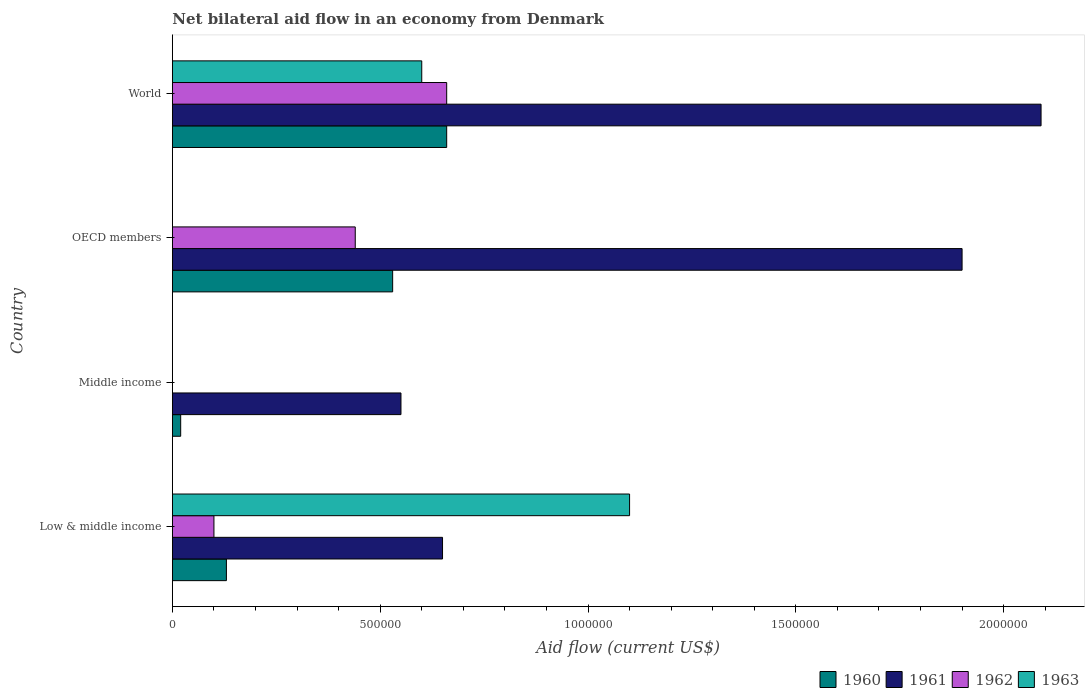How many different coloured bars are there?
Your answer should be compact. 4. Are the number of bars per tick equal to the number of legend labels?
Keep it short and to the point. No. Are the number of bars on each tick of the Y-axis equal?
Provide a succinct answer. No. What is the label of the 3rd group of bars from the top?
Your answer should be compact. Middle income. What is the net bilateral aid flow in 1963 in Low & middle income?
Provide a short and direct response. 1.10e+06. Across all countries, what is the maximum net bilateral aid flow in 1963?
Offer a terse response. 1.10e+06. Across all countries, what is the minimum net bilateral aid flow in 1961?
Offer a terse response. 5.50e+05. What is the total net bilateral aid flow in 1961 in the graph?
Ensure brevity in your answer.  5.19e+06. What is the difference between the net bilateral aid flow in 1960 in OECD members and the net bilateral aid flow in 1962 in Low & middle income?
Offer a very short reply. 4.30e+05. What is the average net bilateral aid flow in 1963 per country?
Your answer should be very brief. 4.25e+05. What is the difference between the net bilateral aid flow in 1961 and net bilateral aid flow in 1963 in Low & middle income?
Provide a succinct answer. -4.50e+05. In how many countries, is the net bilateral aid flow in 1963 greater than 1000000 US$?
Give a very brief answer. 1. What is the ratio of the net bilateral aid flow in 1961 in Middle income to that in OECD members?
Offer a terse response. 0.29. What is the difference between the highest and the lowest net bilateral aid flow in 1961?
Provide a succinct answer. 1.54e+06. Is it the case that in every country, the sum of the net bilateral aid flow in 1963 and net bilateral aid flow in 1962 is greater than the sum of net bilateral aid flow in 1961 and net bilateral aid flow in 1960?
Provide a short and direct response. No. How many bars are there?
Offer a very short reply. 13. Are all the bars in the graph horizontal?
Your response must be concise. Yes. How many countries are there in the graph?
Offer a very short reply. 4. Does the graph contain grids?
Offer a terse response. No. How many legend labels are there?
Provide a succinct answer. 4. What is the title of the graph?
Give a very brief answer. Net bilateral aid flow in an economy from Denmark. Does "1969" appear as one of the legend labels in the graph?
Give a very brief answer. No. What is the label or title of the Y-axis?
Give a very brief answer. Country. What is the Aid flow (current US$) of 1961 in Low & middle income?
Your answer should be compact. 6.50e+05. What is the Aid flow (current US$) of 1963 in Low & middle income?
Offer a very short reply. 1.10e+06. What is the Aid flow (current US$) of 1961 in Middle income?
Provide a succinct answer. 5.50e+05. What is the Aid flow (current US$) of 1962 in Middle income?
Offer a very short reply. 0. What is the Aid flow (current US$) in 1960 in OECD members?
Your answer should be very brief. 5.30e+05. What is the Aid flow (current US$) in 1961 in OECD members?
Your answer should be very brief. 1.90e+06. What is the Aid flow (current US$) in 1962 in OECD members?
Your response must be concise. 4.40e+05. What is the Aid flow (current US$) in 1963 in OECD members?
Offer a terse response. 0. What is the Aid flow (current US$) of 1960 in World?
Provide a succinct answer. 6.60e+05. What is the Aid flow (current US$) in 1961 in World?
Offer a very short reply. 2.09e+06. What is the Aid flow (current US$) in 1962 in World?
Your response must be concise. 6.60e+05. What is the Aid flow (current US$) in 1963 in World?
Your answer should be very brief. 6.00e+05. Across all countries, what is the maximum Aid flow (current US$) of 1961?
Your answer should be very brief. 2.09e+06. Across all countries, what is the maximum Aid flow (current US$) of 1963?
Keep it short and to the point. 1.10e+06. Across all countries, what is the minimum Aid flow (current US$) of 1960?
Your answer should be compact. 2.00e+04. Across all countries, what is the minimum Aid flow (current US$) in 1961?
Offer a very short reply. 5.50e+05. Across all countries, what is the minimum Aid flow (current US$) in 1962?
Give a very brief answer. 0. What is the total Aid flow (current US$) in 1960 in the graph?
Offer a very short reply. 1.34e+06. What is the total Aid flow (current US$) of 1961 in the graph?
Ensure brevity in your answer.  5.19e+06. What is the total Aid flow (current US$) of 1962 in the graph?
Provide a succinct answer. 1.20e+06. What is the total Aid flow (current US$) in 1963 in the graph?
Make the answer very short. 1.70e+06. What is the difference between the Aid flow (current US$) of 1960 in Low & middle income and that in OECD members?
Your answer should be compact. -4.00e+05. What is the difference between the Aid flow (current US$) in 1961 in Low & middle income and that in OECD members?
Your response must be concise. -1.25e+06. What is the difference between the Aid flow (current US$) of 1960 in Low & middle income and that in World?
Give a very brief answer. -5.30e+05. What is the difference between the Aid flow (current US$) of 1961 in Low & middle income and that in World?
Keep it short and to the point. -1.44e+06. What is the difference between the Aid flow (current US$) in 1962 in Low & middle income and that in World?
Ensure brevity in your answer.  -5.60e+05. What is the difference between the Aid flow (current US$) of 1960 in Middle income and that in OECD members?
Make the answer very short. -5.10e+05. What is the difference between the Aid flow (current US$) of 1961 in Middle income and that in OECD members?
Provide a short and direct response. -1.35e+06. What is the difference between the Aid flow (current US$) of 1960 in Middle income and that in World?
Provide a short and direct response. -6.40e+05. What is the difference between the Aid flow (current US$) in 1961 in Middle income and that in World?
Keep it short and to the point. -1.54e+06. What is the difference between the Aid flow (current US$) of 1960 in Low & middle income and the Aid flow (current US$) of 1961 in Middle income?
Provide a short and direct response. -4.20e+05. What is the difference between the Aid flow (current US$) in 1960 in Low & middle income and the Aid flow (current US$) in 1961 in OECD members?
Make the answer very short. -1.77e+06. What is the difference between the Aid flow (current US$) of 1960 in Low & middle income and the Aid flow (current US$) of 1962 in OECD members?
Offer a terse response. -3.10e+05. What is the difference between the Aid flow (current US$) of 1960 in Low & middle income and the Aid flow (current US$) of 1961 in World?
Provide a short and direct response. -1.96e+06. What is the difference between the Aid flow (current US$) in 1960 in Low & middle income and the Aid flow (current US$) in 1962 in World?
Provide a succinct answer. -5.30e+05. What is the difference between the Aid flow (current US$) in 1960 in Low & middle income and the Aid flow (current US$) in 1963 in World?
Provide a short and direct response. -4.70e+05. What is the difference between the Aid flow (current US$) in 1961 in Low & middle income and the Aid flow (current US$) in 1962 in World?
Provide a short and direct response. -10000. What is the difference between the Aid flow (current US$) in 1961 in Low & middle income and the Aid flow (current US$) in 1963 in World?
Your answer should be compact. 5.00e+04. What is the difference between the Aid flow (current US$) in 1962 in Low & middle income and the Aid flow (current US$) in 1963 in World?
Provide a succinct answer. -5.00e+05. What is the difference between the Aid flow (current US$) of 1960 in Middle income and the Aid flow (current US$) of 1961 in OECD members?
Provide a short and direct response. -1.88e+06. What is the difference between the Aid flow (current US$) of 1960 in Middle income and the Aid flow (current US$) of 1962 in OECD members?
Offer a very short reply. -4.20e+05. What is the difference between the Aid flow (current US$) of 1961 in Middle income and the Aid flow (current US$) of 1962 in OECD members?
Give a very brief answer. 1.10e+05. What is the difference between the Aid flow (current US$) of 1960 in Middle income and the Aid flow (current US$) of 1961 in World?
Offer a very short reply. -2.07e+06. What is the difference between the Aid flow (current US$) of 1960 in Middle income and the Aid flow (current US$) of 1962 in World?
Keep it short and to the point. -6.40e+05. What is the difference between the Aid flow (current US$) in 1960 in Middle income and the Aid flow (current US$) in 1963 in World?
Your answer should be very brief. -5.80e+05. What is the difference between the Aid flow (current US$) of 1960 in OECD members and the Aid flow (current US$) of 1961 in World?
Ensure brevity in your answer.  -1.56e+06. What is the difference between the Aid flow (current US$) in 1960 in OECD members and the Aid flow (current US$) in 1962 in World?
Your response must be concise. -1.30e+05. What is the difference between the Aid flow (current US$) in 1960 in OECD members and the Aid flow (current US$) in 1963 in World?
Your response must be concise. -7.00e+04. What is the difference between the Aid flow (current US$) in 1961 in OECD members and the Aid flow (current US$) in 1962 in World?
Keep it short and to the point. 1.24e+06. What is the difference between the Aid flow (current US$) in 1961 in OECD members and the Aid flow (current US$) in 1963 in World?
Provide a succinct answer. 1.30e+06. What is the average Aid flow (current US$) of 1960 per country?
Offer a terse response. 3.35e+05. What is the average Aid flow (current US$) of 1961 per country?
Provide a succinct answer. 1.30e+06. What is the average Aid flow (current US$) of 1962 per country?
Offer a very short reply. 3.00e+05. What is the average Aid flow (current US$) of 1963 per country?
Give a very brief answer. 4.25e+05. What is the difference between the Aid flow (current US$) of 1960 and Aid flow (current US$) of 1961 in Low & middle income?
Offer a very short reply. -5.20e+05. What is the difference between the Aid flow (current US$) of 1960 and Aid flow (current US$) of 1963 in Low & middle income?
Offer a very short reply. -9.70e+05. What is the difference between the Aid flow (current US$) of 1961 and Aid flow (current US$) of 1962 in Low & middle income?
Your answer should be very brief. 5.50e+05. What is the difference between the Aid flow (current US$) in 1961 and Aid flow (current US$) in 1963 in Low & middle income?
Keep it short and to the point. -4.50e+05. What is the difference between the Aid flow (current US$) in 1962 and Aid flow (current US$) in 1963 in Low & middle income?
Your answer should be very brief. -1.00e+06. What is the difference between the Aid flow (current US$) in 1960 and Aid flow (current US$) in 1961 in Middle income?
Ensure brevity in your answer.  -5.30e+05. What is the difference between the Aid flow (current US$) in 1960 and Aid flow (current US$) in 1961 in OECD members?
Keep it short and to the point. -1.37e+06. What is the difference between the Aid flow (current US$) in 1961 and Aid flow (current US$) in 1962 in OECD members?
Give a very brief answer. 1.46e+06. What is the difference between the Aid flow (current US$) of 1960 and Aid flow (current US$) of 1961 in World?
Provide a short and direct response. -1.43e+06. What is the difference between the Aid flow (current US$) of 1960 and Aid flow (current US$) of 1962 in World?
Offer a very short reply. 0. What is the difference between the Aid flow (current US$) of 1960 and Aid flow (current US$) of 1963 in World?
Your answer should be very brief. 6.00e+04. What is the difference between the Aid flow (current US$) of 1961 and Aid flow (current US$) of 1962 in World?
Provide a succinct answer. 1.43e+06. What is the difference between the Aid flow (current US$) in 1961 and Aid flow (current US$) in 1963 in World?
Make the answer very short. 1.49e+06. What is the ratio of the Aid flow (current US$) of 1961 in Low & middle income to that in Middle income?
Give a very brief answer. 1.18. What is the ratio of the Aid flow (current US$) in 1960 in Low & middle income to that in OECD members?
Keep it short and to the point. 0.25. What is the ratio of the Aid flow (current US$) in 1961 in Low & middle income to that in OECD members?
Provide a succinct answer. 0.34. What is the ratio of the Aid flow (current US$) in 1962 in Low & middle income to that in OECD members?
Make the answer very short. 0.23. What is the ratio of the Aid flow (current US$) in 1960 in Low & middle income to that in World?
Your answer should be compact. 0.2. What is the ratio of the Aid flow (current US$) of 1961 in Low & middle income to that in World?
Give a very brief answer. 0.31. What is the ratio of the Aid flow (current US$) of 1962 in Low & middle income to that in World?
Keep it short and to the point. 0.15. What is the ratio of the Aid flow (current US$) of 1963 in Low & middle income to that in World?
Provide a succinct answer. 1.83. What is the ratio of the Aid flow (current US$) in 1960 in Middle income to that in OECD members?
Offer a very short reply. 0.04. What is the ratio of the Aid flow (current US$) of 1961 in Middle income to that in OECD members?
Offer a terse response. 0.29. What is the ratio of the Aid flow (current US$) of 1960 in Middle income to that in World?
Provide a succinct answer. 0.03. What is the ratio of the Aid flow (current US$) in 1961 in Middle income to that in World?
Give a very brief answer. 0.26. What is the ratio of the Aid flow (current US$) in 1960 in OECD members to that in World?
Provide a short and direct response. 0.8. What is the ratio of the Aid flow (current US$) in 1961 in OECD members to that in World?
Your answer should be very brief. 0.91. What is the difference between the highest and the second highest Aid flow (current US$) of 1960?
Keep it short and to the point. 1.30e+05. What is the difference between the highest and the lowest Aid flow (current US$) of 1960?
Keep it short and to the point. 6.40e+05. What is the difference between the highest and the lowest Aid flow (current US$) of 1961?
Give a very brief answer. 1.54e+06. What is the difference between the highest and the lowest Aid flow (current US$) in 1963?
Your answer should be very brief. 1.10e+06. 